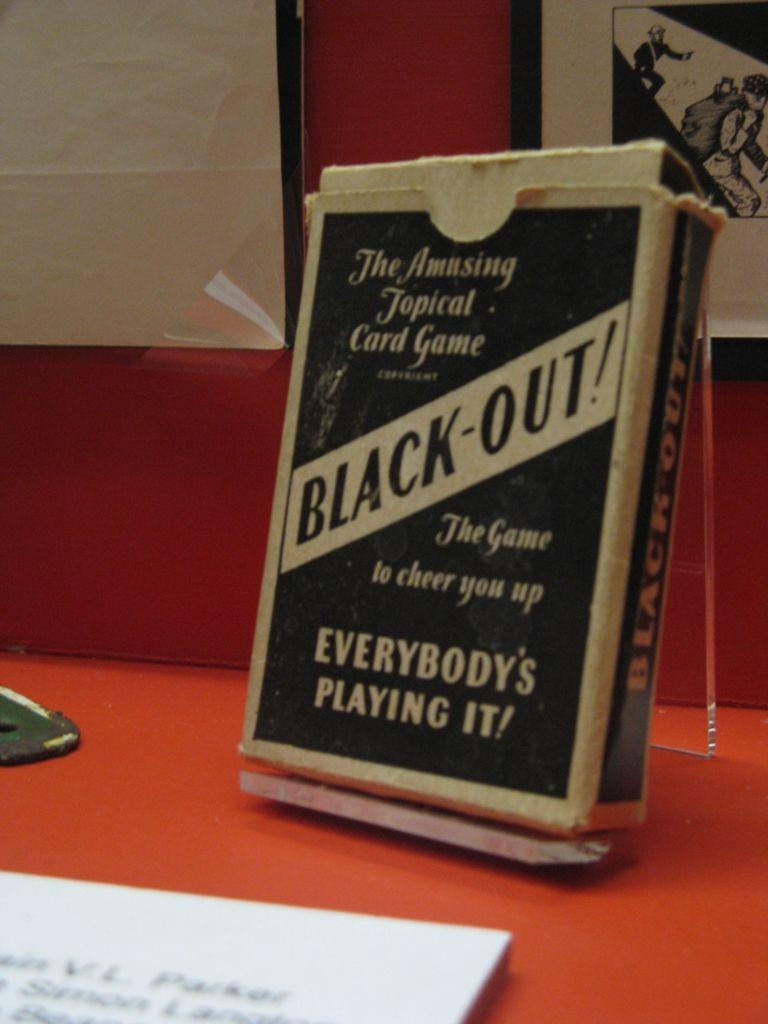<image>
Present a compact description of the photo's key features. The Amusing topical card game black-out game that cheer you up. 